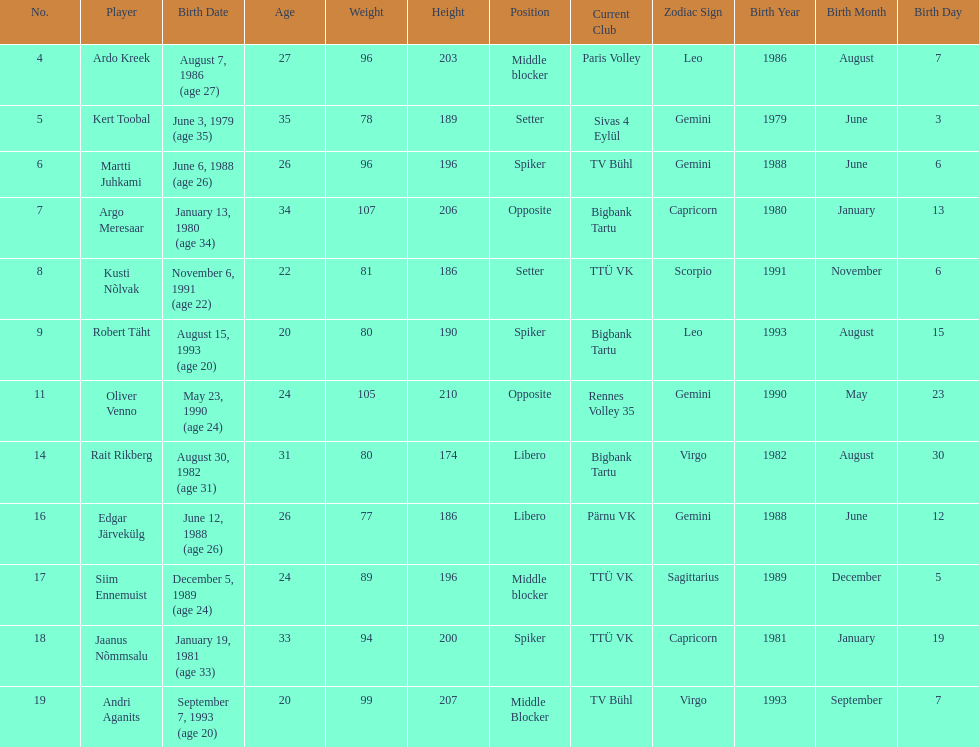Among the members of the estonian men's national volleyball team, how many have a birth year of 1988? 2. 